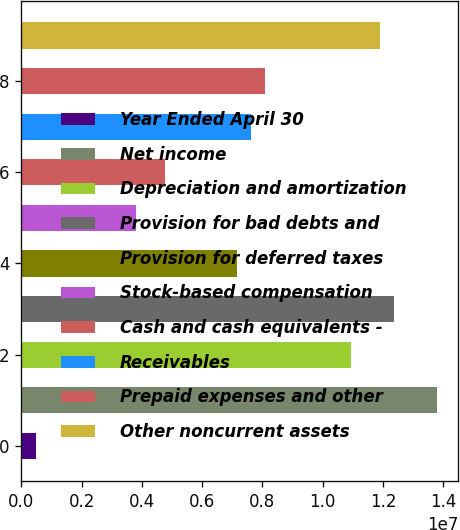Convert chart to OTSL. <chart><loc_0><loc_0><loc_500><loc_500><bar_chart><fcel>Year Ended April 30<fcel>Net income<fcel>Depreciation and amortization<fcel>Provision for bad debts and<fcel>Provision for deferred taxes<fcel>Stock-based compensation<fcel>Cash and cash equivalents -<fcel>Receivables<fcel>Prepaid expenses and other<fcel>Other noncurrent assets<nl><fcel>477663<fcel>1.38076e+07<fcel>1.09512e+07<fcel>1.23794e+07<fcel>7.14264e+06<fcel>3.81015e+06<fcel>4.76229e+06<fcel>7.61871e+06<fcel>8.09478e+06<fcel>1.19033e+07<nl></chart> 